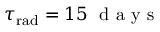<formula> <loc_0><loc_0><loc_500><loc_500>\tau _ { r a d } = 1 5 d a y s</formula> 